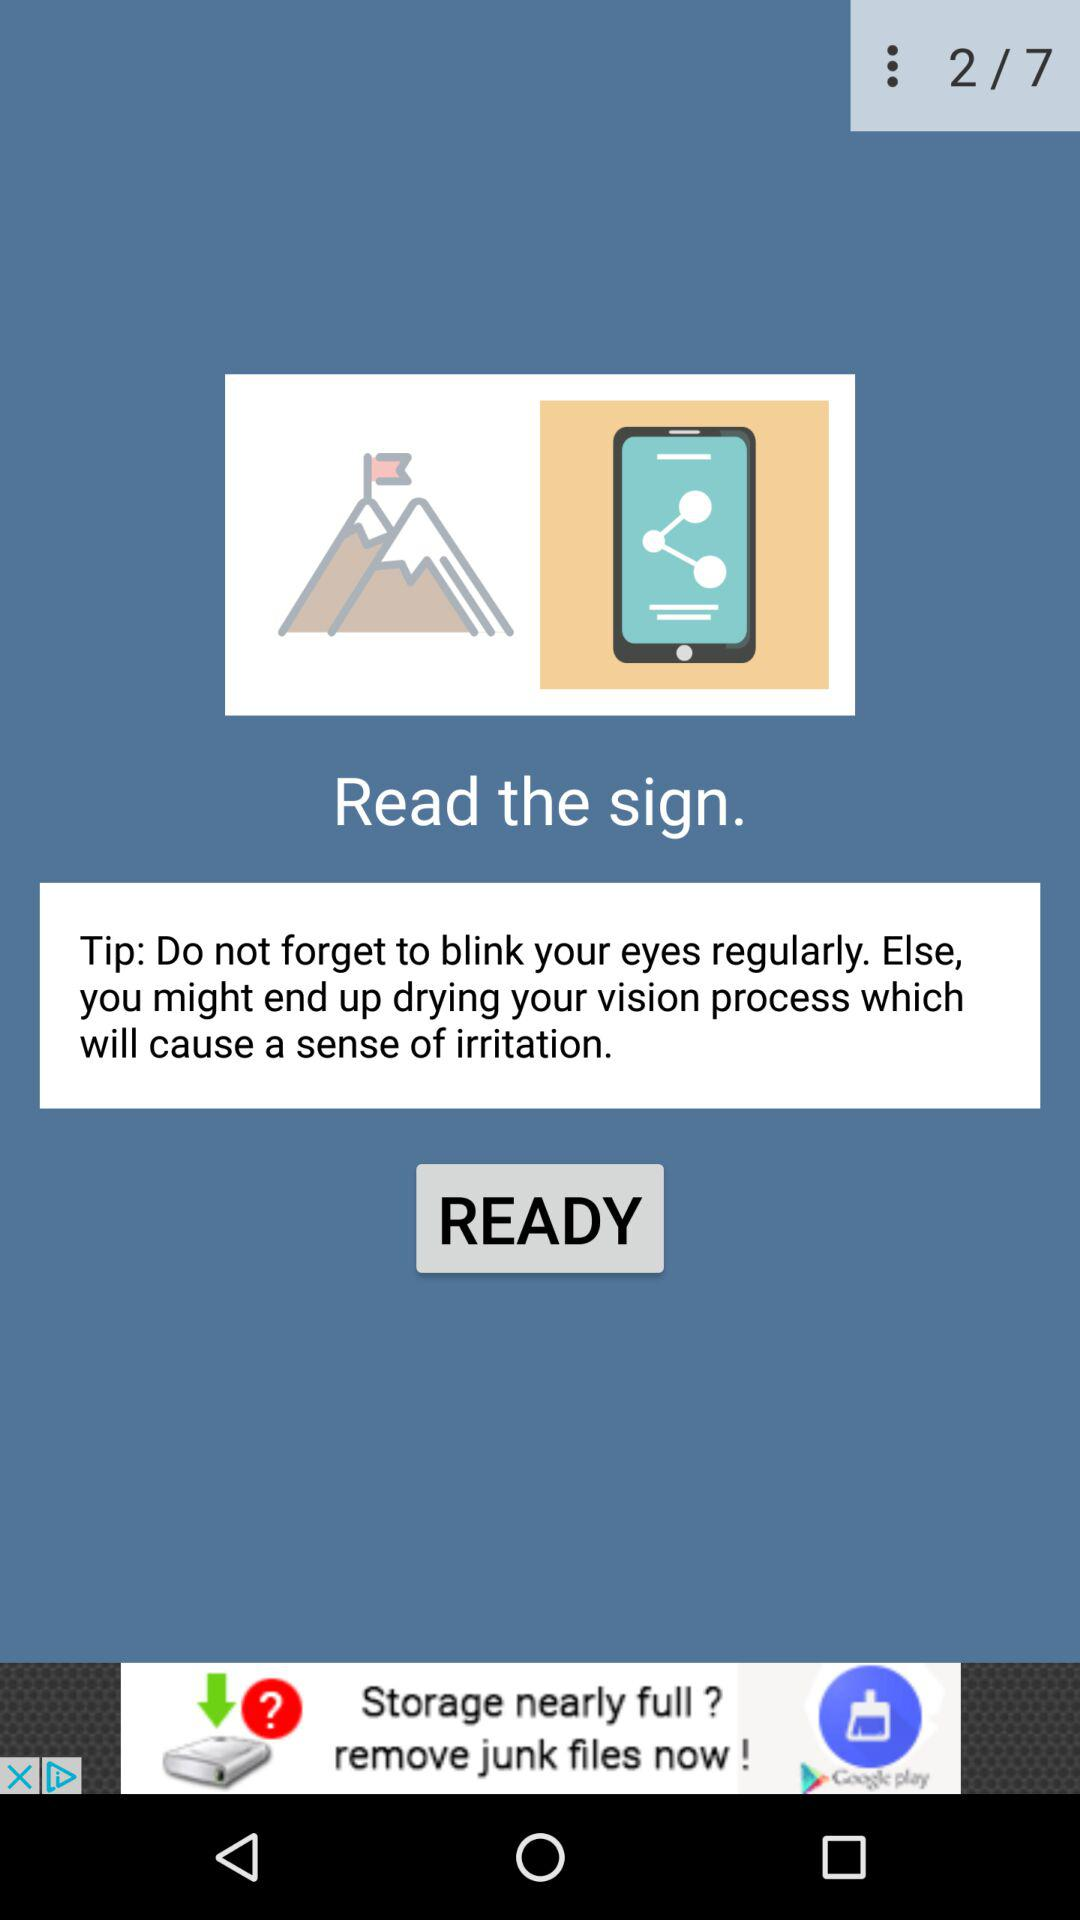How many more steps are left to complete the task?
Answer the question using a single word or phrase. 5 